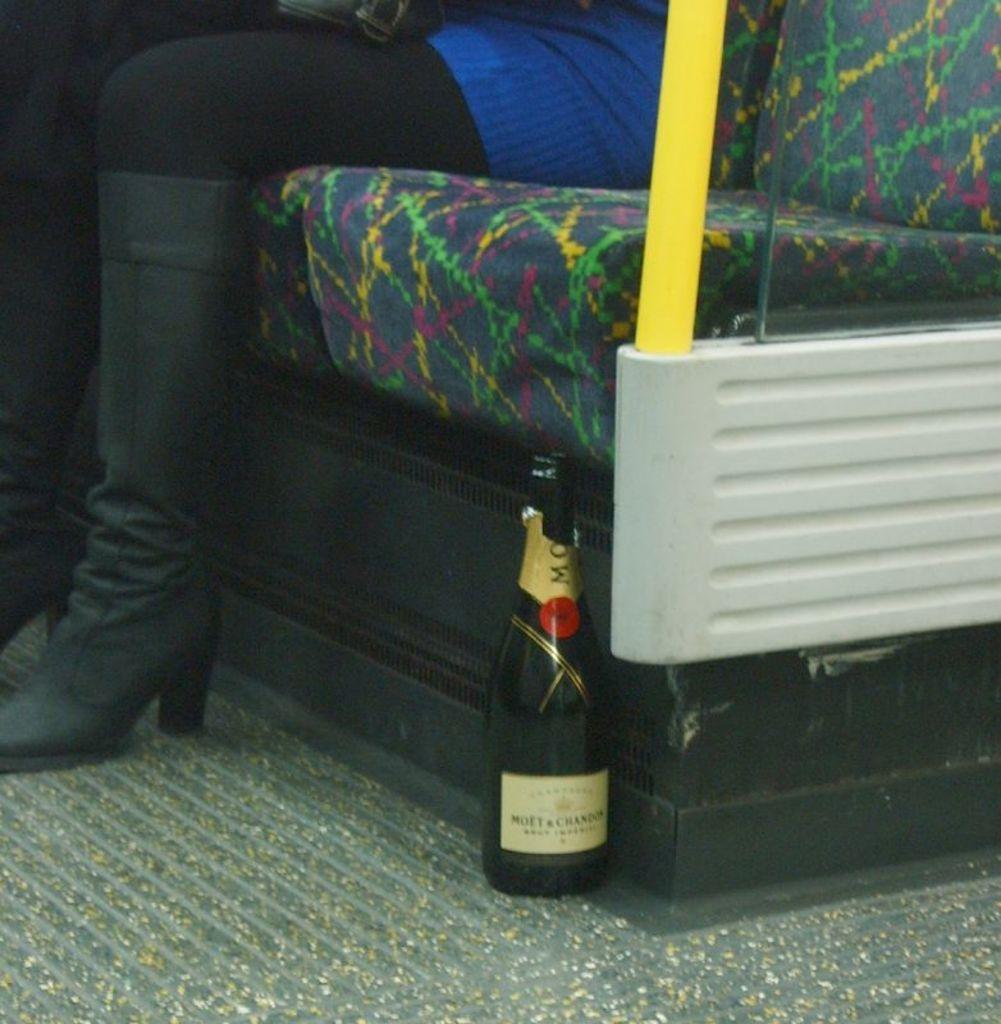How would you summarize this image in a sentence or two? There is a bottle in the center of the image and there is a lady who is sitting on a seat at the top side. 